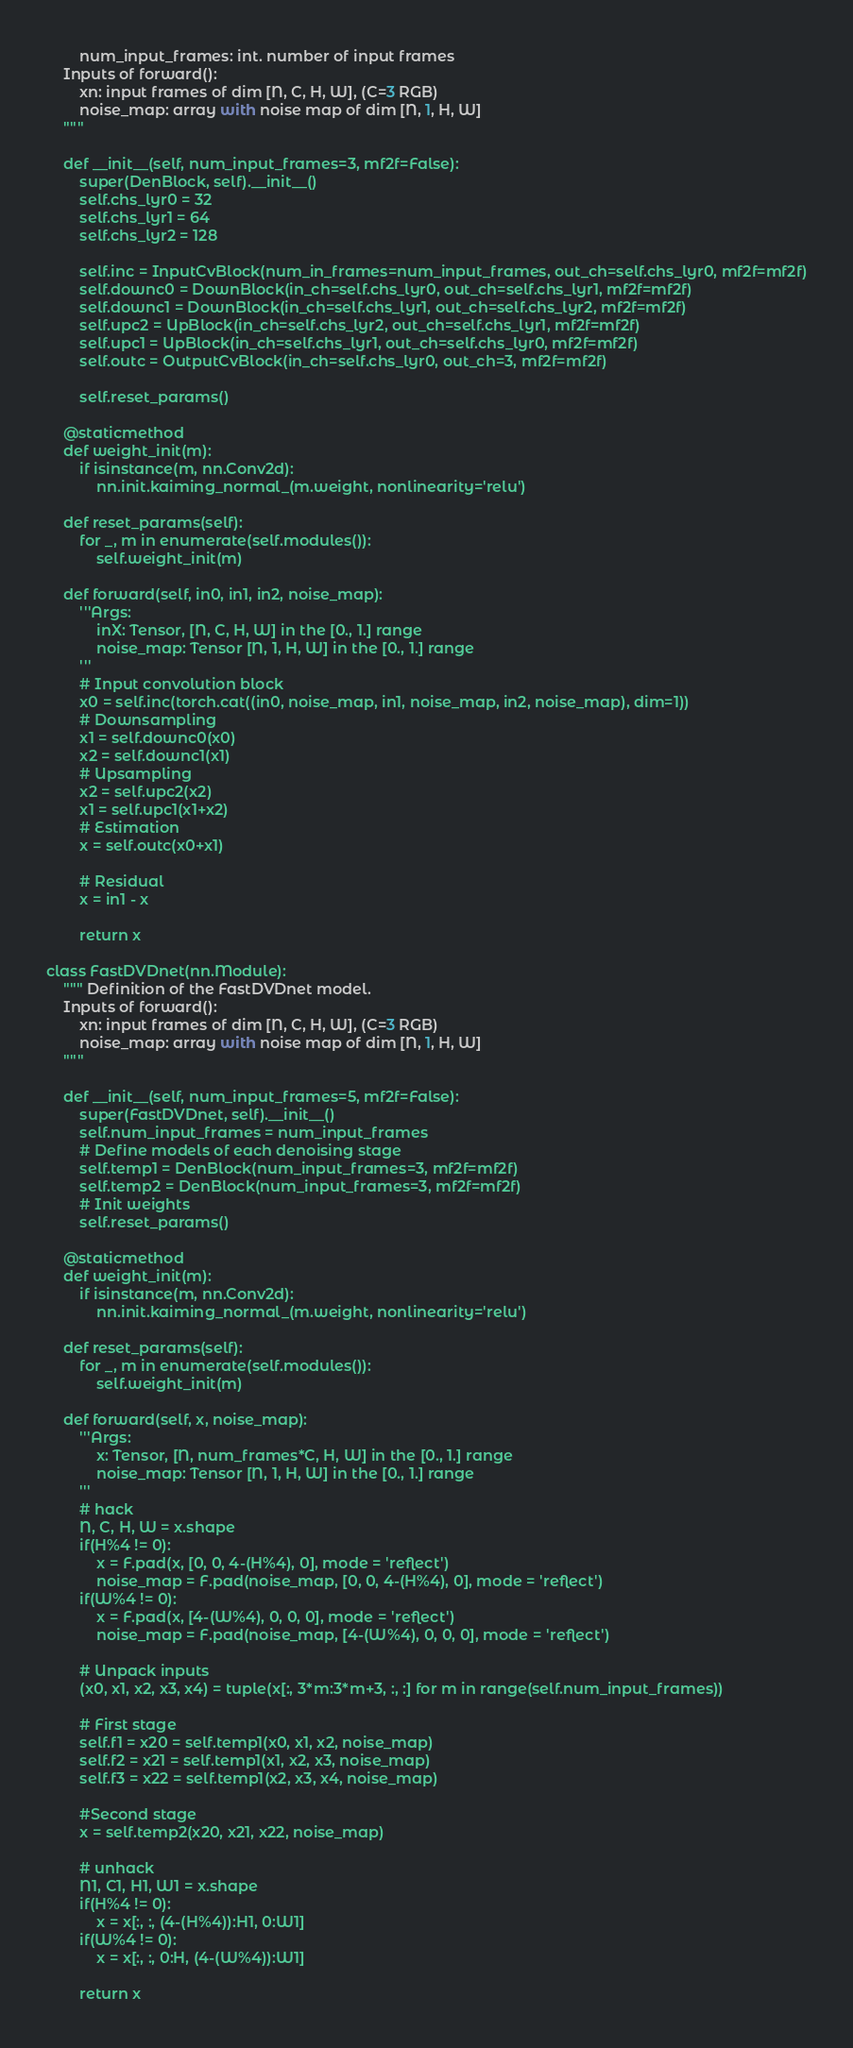<code> <loc_0><loc_0><loc_500><loc_500><_Python_>        num_input_frames: int. number of input frames
    Inputs of forward():
        xn: input frames of dim [N, C, H, W], (C=3 RGB)
        noise_map: array with noise map of dim [N, 1, H, W]
    """

    def __init__(self, num_input_frames=3, mf2f=False):
        super(DenBlock, self).__init__()
        self.chs_lyr0 = 32
        self.chs_lyr1 = 64
        self.chs_lyr2 = 128

        self.inc = InputCvBlock(num_in_frames=num_input_frames, out_ch=self.chs_lyr0, mf2f=mf2f)
        self.downc0 = DownBlock(in_ch=self.chs_lyr0, out_ch=self.chs_lyr1, mf2f=mf2f)
        self.downc1 = DownBlock(in_ch=self.chs_lyr1, out_ch=self.chs_lyr2, mf2f=mf2f)
        self.upc2 = UpBlock(in_ch=self.chs_lyr2, out_ch=self.chs_lyr1, mf2f=mf2f)
        self.upc1 = UpBlock(in_ch=self.chs_lyr1, out_ch=self.chs_lyr0, mf2f=mf2f)
        self.outc = OutputCvBlock(in_ch=self.chs_lyr0, out_ch=3, mf2f=mf2f)

        self.reset_params()

    @staticmethod
    def weight_init(m):
        if isinstance(m, nn.Conv2d):
            nn.init.kaiming_normal_(m.weight, nonlinearity='relu')

    def reset_params(self):
        for _, m in enumerate(self.modules()):
            self.weight_init(m)

    def forward(self, in0, in1, in2, noise_map):
        '''Args:
            inX: Tensor, [N, C, H, W] in the [0., 1.] range
            noise_map: Tensor [N, 1, H, W] in the [0., 1.] range
        '''
        # Input convolution block
        x0 = self.inc(torch.cat((in0, noise_map, in1, noise_map, in2, noise_map), dim=1))
        # Downsampling
        x1 = self.downc0(x0)
        x2 = self.downc1(x1)
        # Upsampling
        x2 = self.upc2(x2)
        x1 = self.upc1(x1+x2)
        # Estimation
        x = self.outc(x0+x1)

        # Residual
        x = in1 - x

        return x

class FastDVDnet(nn.Module):
    """ Definition of the FastDVDnet model.
    Inputs of forward():
        xn: input frames of dim [N, C, H, W], (C=3 RGB)
        noise_map: array with noise map of dim [N, 1, H, W]
    """

    def __init__(self, num_input_frames=5, mf2f=False):
        super(FastDVDnet, self).__init__()
        self.num_input_frames = num_input_frames
        # Define models of each denoising stage
        self.temp1 = DenBlock(num_input_frames=3, mf2f=mf2f)
        self.temp2 = DenBlock(num_input_frames=3, mf2f=mf2f)
        # Init weights
        self.reset_params()

    @staticmethod
    def weight_init(m):
        if isinstance(m, nn.Conv2d):
            nn.init.kaiming_normal_(m.weight, nonlinearity='relu')

    def reset_params(self):
        for _, m in enumerate(self.modules()):
            self.weight_init(m)

    def forward(self, x, noise_map):
        '''Args:
            x: Tensor, [N, num_frames*C, H, W] in the [0., 1.] range
            noise_map: Tensor [N, 1, H, W] in the [0., 1.] range
        '''
        # hack
        N, C, H, W = x.shape
        if(H%4 != 0):
            x = F.pad(x, [0, 0, 4-(H%4), 0], mode = 'reflect')
            noise_map = F.pad(noise_map, [0, 0, 4-(H%4), 0], mode = 'reflect')
        if(W%4 != 0):
            x = F.pad(x, [4-(W%4), 0, 0, 0], mode = 'reflect')
            noise_map = F.pad(noise_map, [4-(W%4), 0, 0, 0], mode = 'reflect')
        
        # Unpack inputs
        (x0, x1, x2, x3, x4) = tuple(x[:, 3*m:3*m+3, :, :] for m in range(self.num_input_frames))

        # First stage
        self.f1 = x20 = self.temp1(x0, x1, x2, noise_map)
        self.f2 = x21 = self.temp1(x1, x2, x3, noise_map)
        self.f3 = x22 = self.temp1(x2, x3, x4, noise_map)

        #Second stage
        x = self.temp2(x20, x21, x22, noise_map)
        
        # unhack
        N1, C1, H1, W1 = x.shape
        if(H%4 != 0):
            x = x[:, :, (4-(H%4)):H1, 0:W1]
        if(W%4 != 0):
            x = x[:, :, 0:H, (4-(W%4)):W1]

        return x</code> 